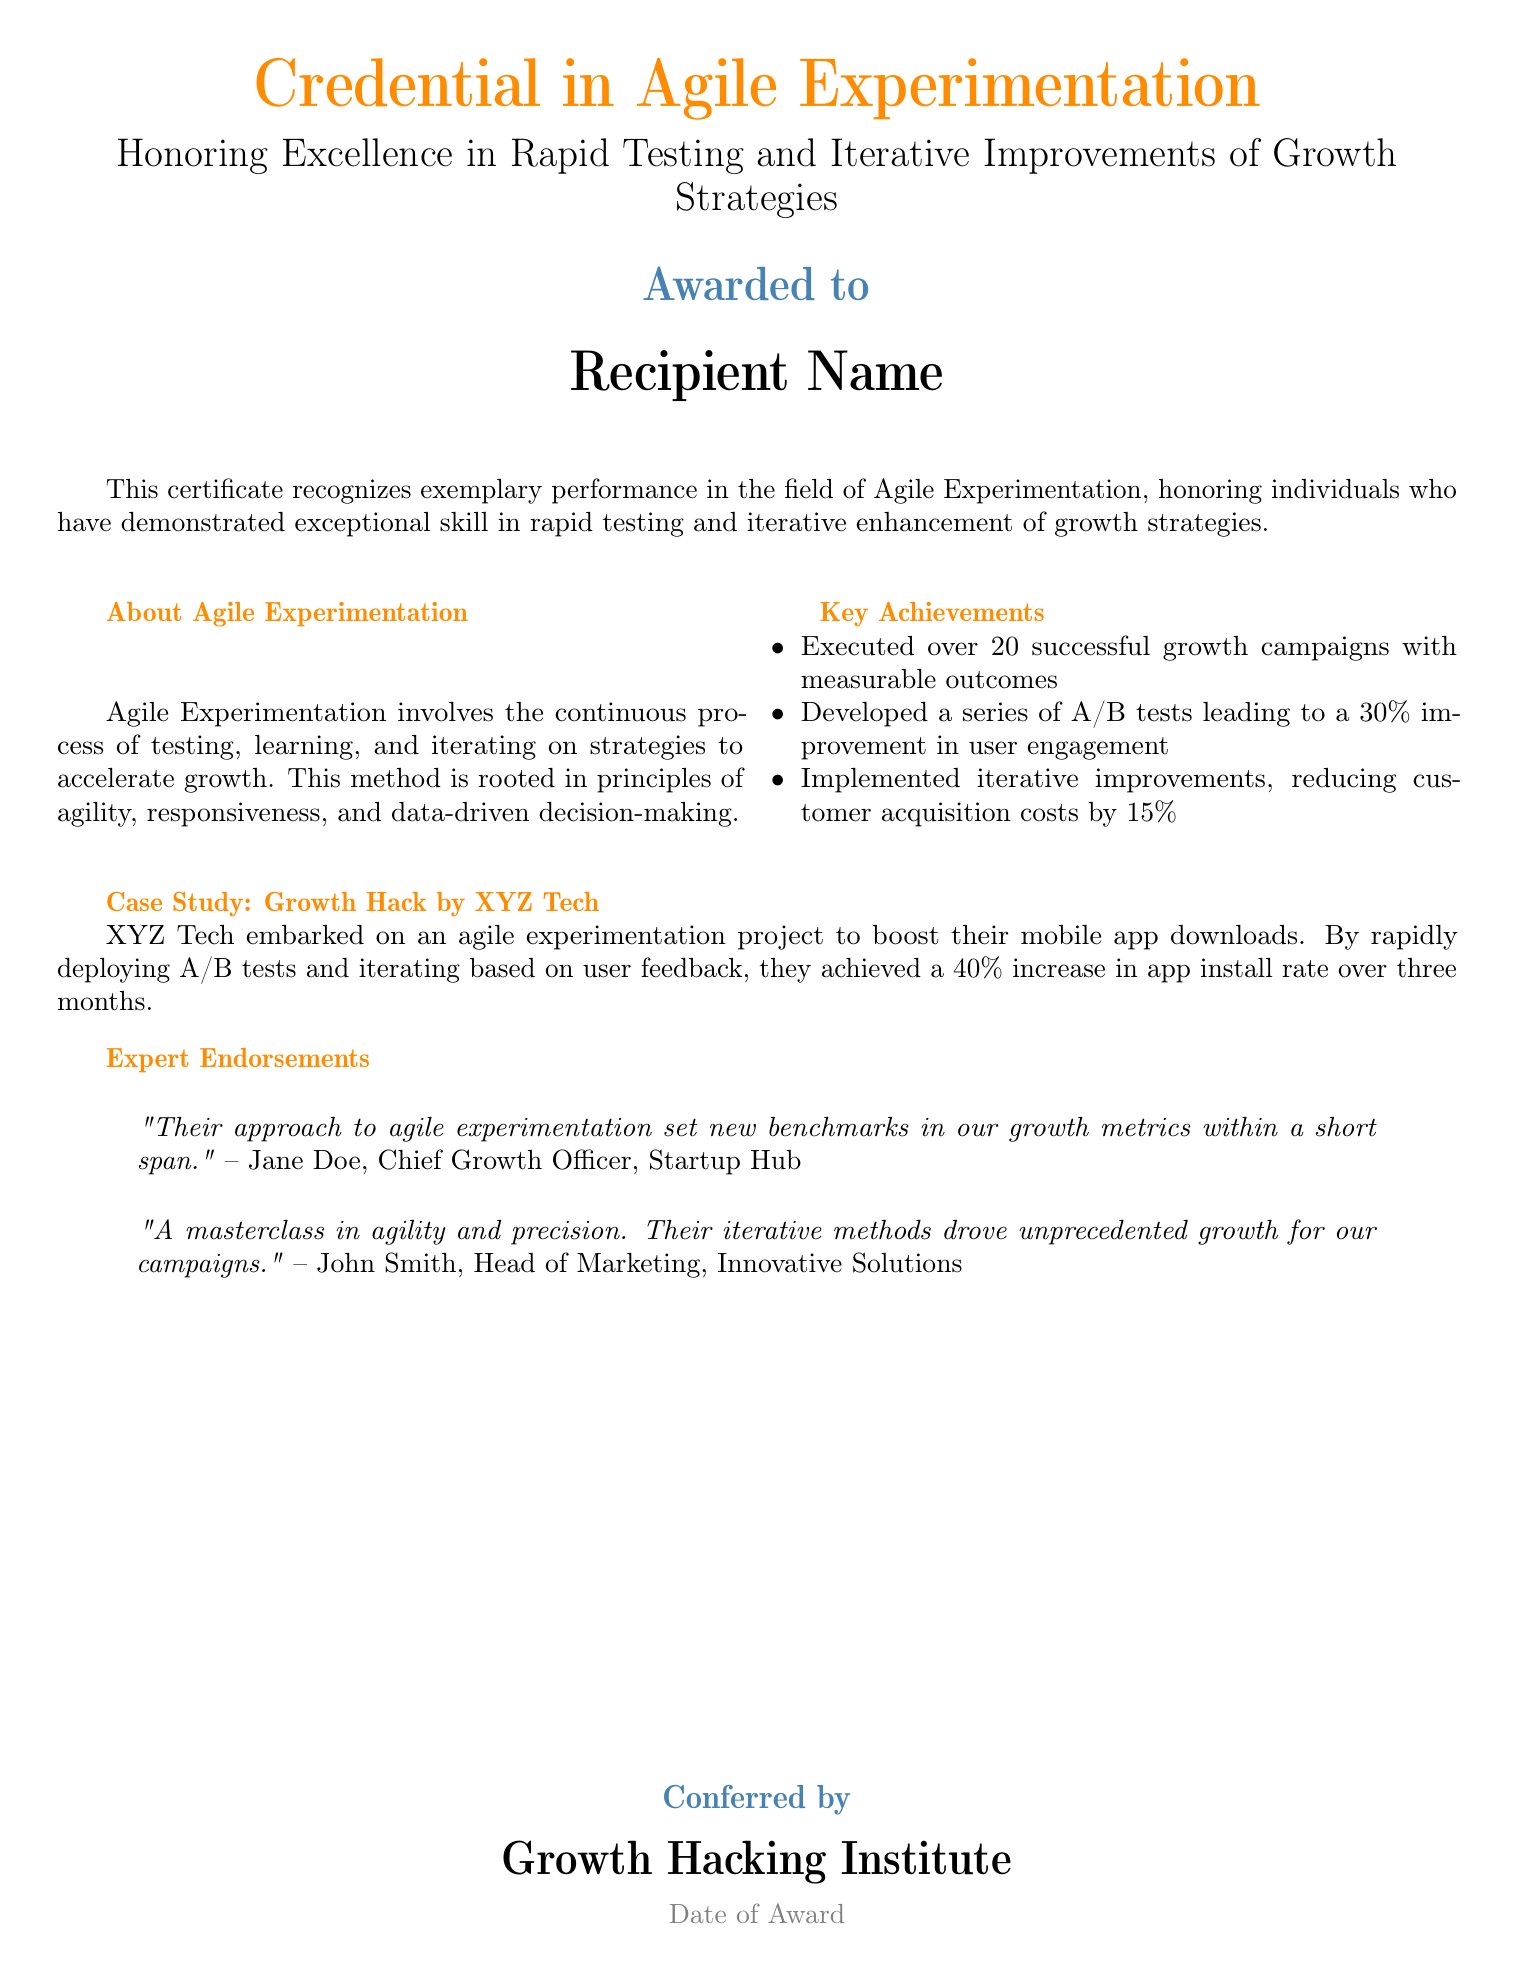What is the title of the certificate? The title of the certificate is prominently displayed at the top of the document.
Answer: Credential in Agile Experimentation What is the award recipient's name? The recipient's name is mentioned in a designated area labeled "Awarded to."
Answer: Recipient Name How many growth campaigns were executed? The document specifies the number of successful growth campaigns executed.
Answer: Over 20 What percentage improvement in user engagement was achieved? The percentage improvement is highlighted in the key achievements section.
Answer: 30% What was the reduction in customer acquisition costs? The reduction in customer acquisition costs is specified in the key achievements section.
Answer: 15% What was the increase in app install rate for XYZ Tech? The increase in app install rate achieved by XYZ Tech is noted in the case study.
Answer: 40% Who conferred the certificate? The organization that conferred the certificate is listed at the bottom of the document.
Answer: Growth Hacking Institute What is the color associated with the main title? The color of the title is specified in the document.
Answer: RGB(255,140,0) Who endorsed the agile experimentation approach? The endorsements provided are attributed to specific individuals mentioned in quotes.
Answer: Jane Doe and John Smith 